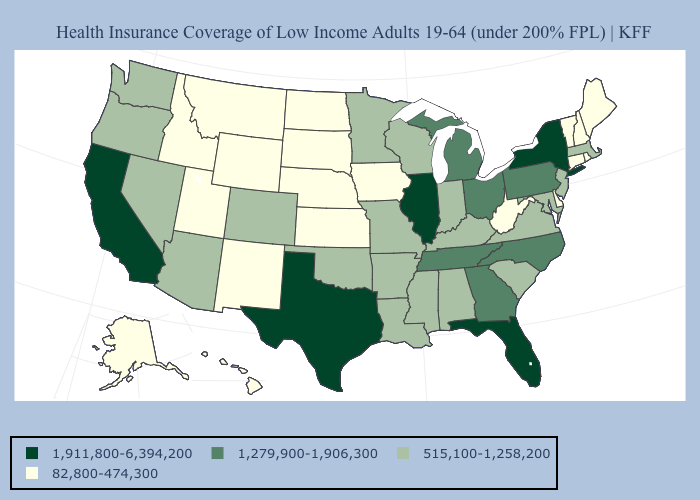Does Colorado have a lower value than Illinois?
Keep it brief. Yes. Does the first symbol in the legend represent the smallest category?
Short answer required. No. Name the states that have a value in the range 82,800-474,300?
Answer briefly. Alaska, Connecticut, Delaware, Hawaii, Idaho, Iowa, Kansas, Maine, Montana, Nebraska, New Hampshire, New Mexico, North Dakota, Rhode Island, South Dakota, Utah, Vermont, West Virginia, Wyoming. Among the states that border Alabama , which have the lowest value?
Write a very short answer. Mississippi. Does Nebraska have the highest value in the USA?
Concise answer only. No. Which states have the lowest value in the West?
Answer briefly. Alaska, Hawaii, Idaho, Montana, New Mexico, Utah, Wyoming. Is the legend a continuous bar?
Write a very short answer. No. What is the value of South Dakota?
Short answer required. 82,800-474,300. Name the states that have a value in the range 82,800-474,300?
Be succinct. Alaska, Connecticut, Delaware, Hawaii, Idaho, Iowa, Kansas, Maine, Montana, Nebraska, New Hampshire, New Mexico, North Dakota, Rhode Island, South Dakota, Utah, Vermont, West Virginia, Wyoming. What is the value of Nebraska?
Answer briefly. 82,800-474,300. Does New Mexico have the highest value in the USA?
Be succinct. No. Name the states that have a value in the range 82,800-474,300?
Short answer required. Alaska, Connecticut, Delaware, Hawaii, Idaho, Iowa, Kansas, Maine, Montana, Nebraska, New Hampshire, New Mexico, North Dakota, Rhode Island, South Dakota, Utah, Vermont, West Virginia, Wyoming. Does New York have the highest value in the Northeast?
Give a very brief answer. Yes. Does Wisconsin have the same value as Florida?
Answer briefly. No. Name the states that have a value in the range 1,279,900-1,906,300?
Write a very short answer. Georgia, Michigan, North Carolina, Ohio, Pennsylvania, Tennessee. 